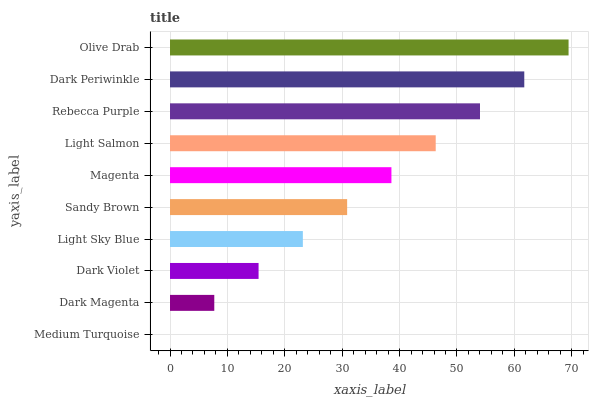Is Medium Turquoise the minimum?
Answer yes or no. Yes. Is Olive Drab the maximum?
Answer yes or no. Yes. Is Dark Magenta the minimum?
Answer yes or no. No. Is Dark Magenta the maximum?
Answer yes or no. No. Is Dark Magenta greater than Medium Turquoise?
Answer yes or no. Yes. Is Medium Turquoise less than Dark Magenta?
Answer yes or no. Yes. Is Medium Turquoise greater than Dark Magenta?
Answer yes or no. No. Is Dark Magenta less than Medium Turquoise?
Answer yes or no. No. Is Magenta the high median?
Answer yes or no. Yes. Is Sandy Brown the low median?
Answer yes or no. Yes. Is Dark Magenta the high median?
Answer yes or no. No. Is Medium Turquoise the low median?
Answer yes or no. No. 